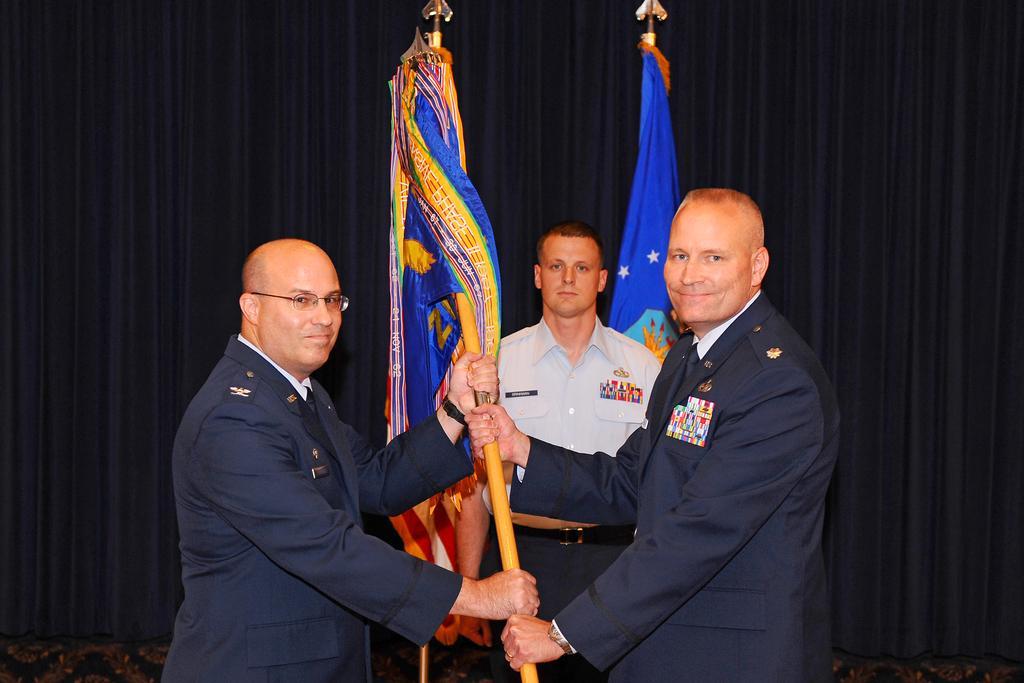In one or two sentences, can you explain what this image depicts? In this image in the front there are persons standing and holding flag in their hands and smiling. In the background there is a man standing and there are flags and there is a curtain which is black in colour. 